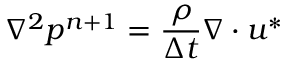Convert formula to latex. <formula><loc_0><loc_0><loc_500><loc_500>\nabla ^ { 2 } p ^ { n + 1 } = \frac { \rho } { \Delta t } \nabla \cdot u ^ { * }</formula> 